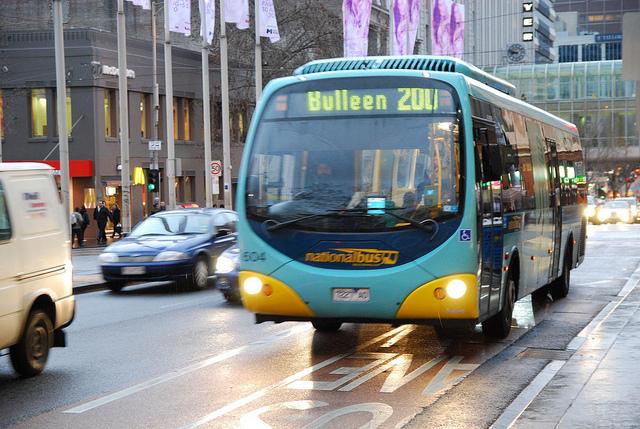Are there other cars on the street?
Write a very short answer. Yes. What is the busses number?
Keep it brief. 200. Where is the bus going?
Keep it brief. Bulleen. 